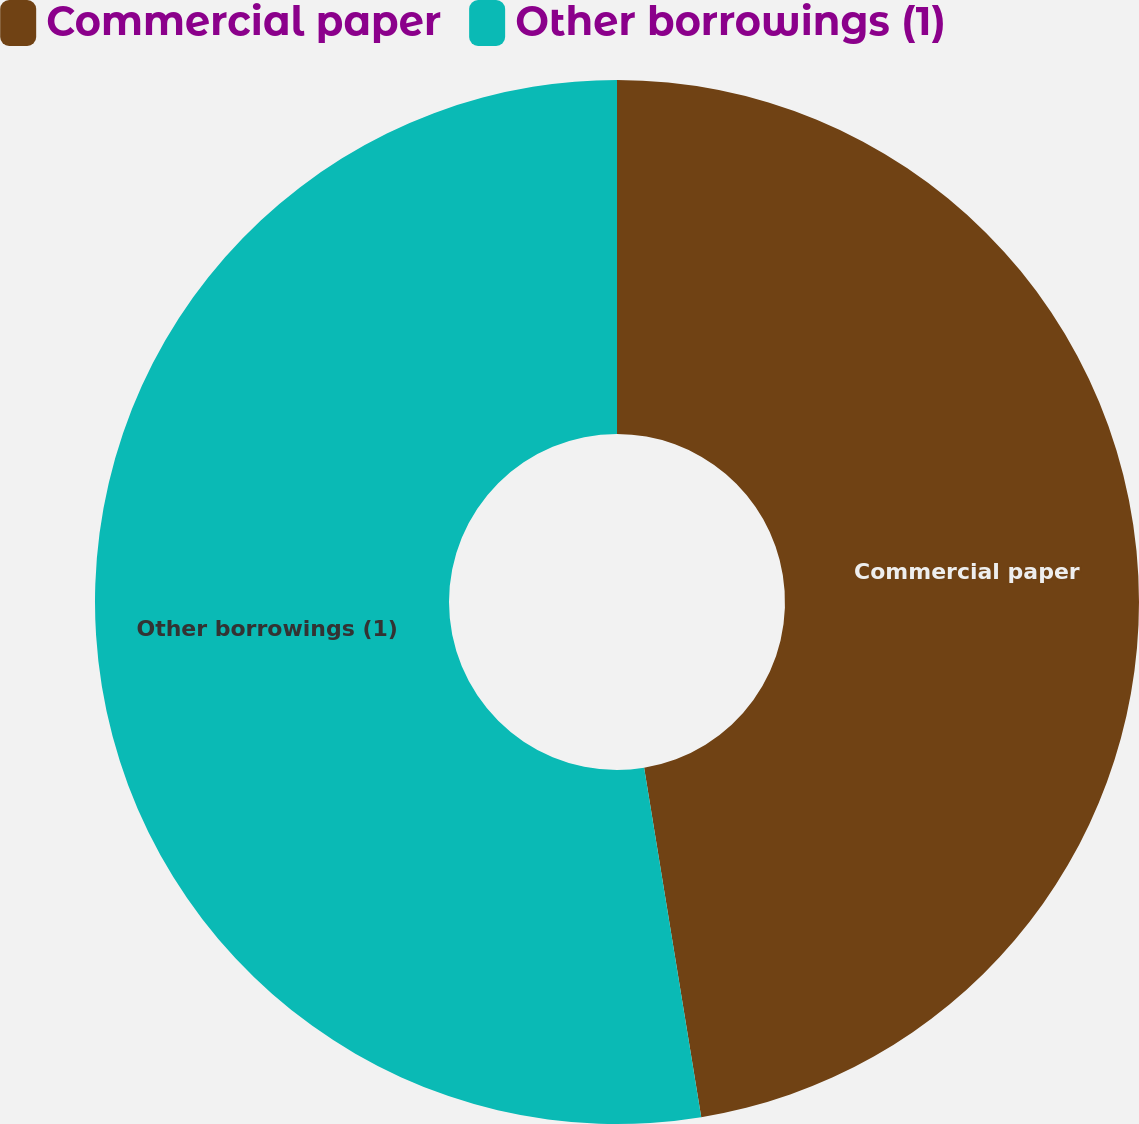<chart> <loc_0><loc_0><loc_500><loc_500><pie_chart><fcel>Commercial paper<fcel>Other borrowings (1)<nl><fcel>47.42%<fcel>52.58%<nl></chart> 